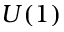<formula> <loc_0><loc_0><loc_500><loc_500>U ( 1 )</formula> 